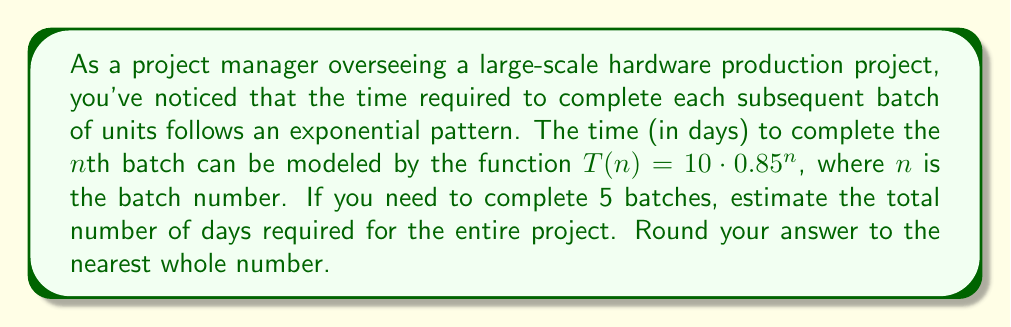Teach me how to tackle this problem. To solve this problem, we need to calculate the sum of the time required for each of the 5 batches. Let's break it down step-by-step:

1) The time function is given as $T(n) = 10 \cdot 0.85^n$

2) We need to calculate $T(1)$, $T(2)$, $T(3)$, $T(4)$, and $T(5)$, then sum these values:

   $T(1) = 10 \cdot 0.85^1 = 10 \cdot 0.85 = 8.5$ days
   $T(2) = 10 \cdot 0.85^2 = 10 \cdot 0.7225 = 7.225$ days
   $T(3) = 10 \cdot 0.85^3 = 10 \cdot 0.614125 = 6.14125$ days
   $T(4) = 10 \cdot 0.85^4 = 10 \cdot 0.52200625 = 5.2200625$ days
   $T(5) = 10 \cdot 0.85^5 = 10 \cdot 0.4437053125 = 4.437053125$ days

3) Now, we sum these values:

   $Total Time = T(1) + T(2) + T(3) + T(4) + T(5)$
   $= 8.5 + 7.225 + 6.14125 + 5.2200625 + 4.437053125$
   $= 31.523365625$ days

4) Rounding to the nearest whole number:

   $31.523365625 \approx 32$ days
Answer: 32 days 